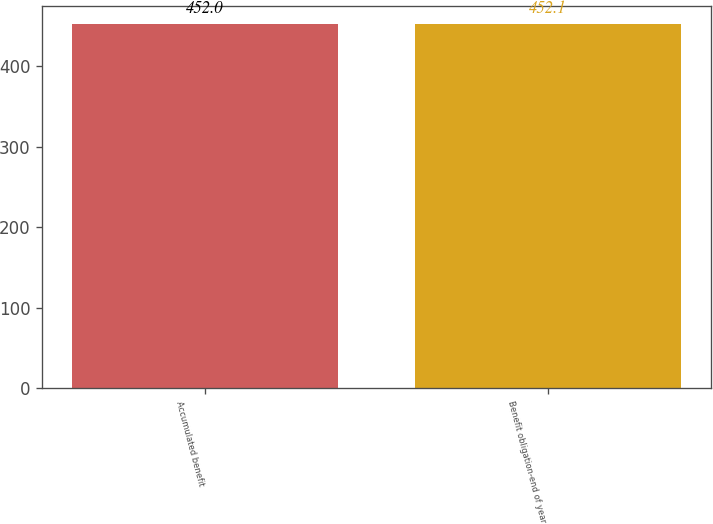Convert chart. <chart><loc_0><loc_0><loc_500><loc_500><bar_chart><fcel>Accumulated benefit<fcel>Benefit obligation-end of year<nl><fcel>452<fcel>452.1<nl></chart> 